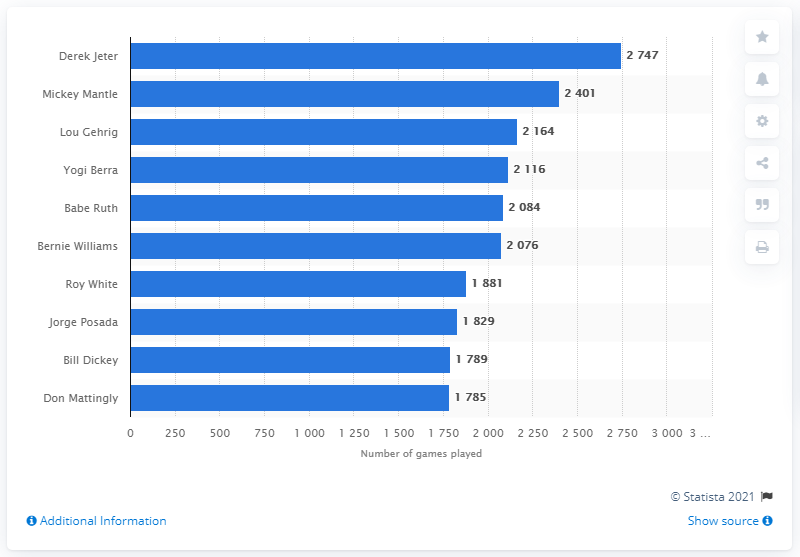Indicate a few pertinent items in this graphic. Derek Jeter, the most accomplished player in New York Yankees franchise history, has played the most games of any player in the team's history. 